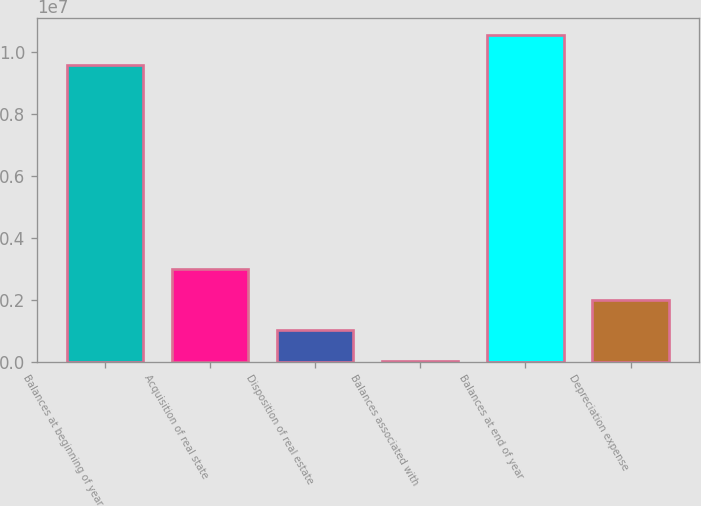Convert chart. <chart><loc_0><loc_0><loc_500><loc_500><bar_chart><fcel>Balances at beginning of year<fcel>Acquisition of real state<fcel>Disposition of real estate<fcel>Balances associated with<fcel>Balances at end of year<fcel>Depreciation expense<nl><fcel>9.58616e+06<fcel>2.99624e+06<fcel>1.01577e+06<fcel>25531<fcel>1.05764e+07<fcel>2.00601e+06<nl></chart> 